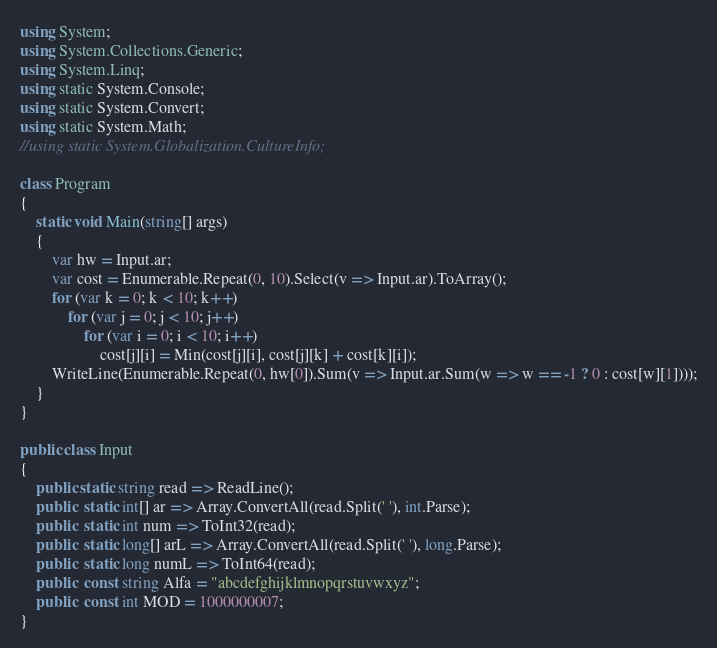<code> <loc_0><loc_0><loc_500><loc_500><_C#_>using System;
using System.Collections.Generic;
using System.Linq;
using static System.Console;
using static System.Convert;
using static System.Math;
//using static System.Globalization.CultureInfo;

class Program
{
    static void Main(string[] args)
    {
        var hw = Input.ar;
        var cost = Enumerable.Repeat(0, 10).Select(v => Input.ar).ToArray();
        for (var k = 0; k < 10; k++)
            for (var j = 0; j < 10; j++)
                for (var i = 0; i < 10; i++)
                    cost[j][i] = Min(cost[j][i], cost[j][k] + cost[k][i]);
        WriteLine(Enumerable.Repeat(0, hw[0]).Sum(v => Input.ar.Sum(w => w == -1 ? 0 : cost[w][1])));
    }
}

public class Input
{
    public static string read => ReadLine();
    public  static int[] ar => Array.ConvertAll(read.Split(' '), int.Parse);
    public  static int num => ToInt32(read);
    public  static long[] arL => Array.ConvertAll(read.Split(' '), long.Parse);
    public  static long numL => ToInt64(read);
    public  const string Alfa = "abcdefghijklmnopqrstuvwxyz";
    public  const int MOD = 1000000007;
}
</code> 